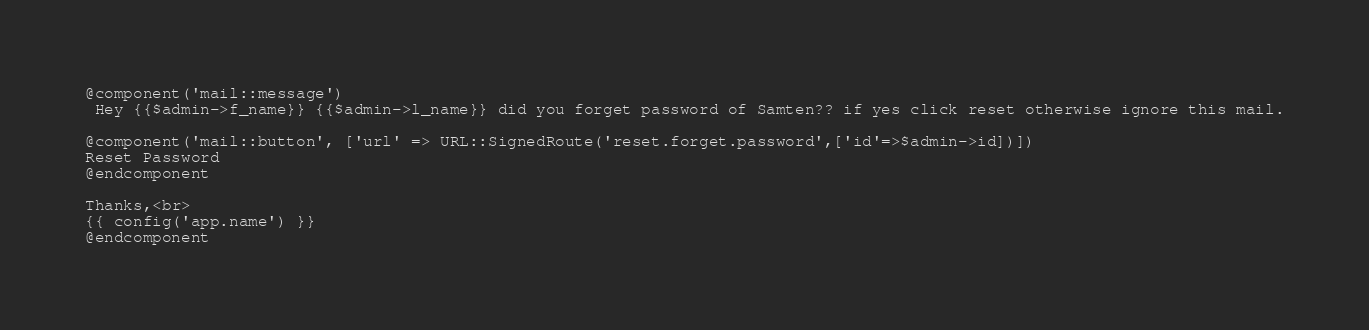Convert code to text. <code><loc_0><loc_0><loc_500><loc_500><_PHP_>@component('mail::message')
 Hey {{$admin->f_name}} {{$admin->l_name}} did you forget password of Samten?? if yes click reset otherwise ignore this mail.

@component('mail::button', ['url' => URL::SignedRoute('reset.forget.password',['id'=>$admin->id])])
Reset Password
@endcomponent

Thanks,<br>
{{ config('app.name') }}
@endcomponent
</code> 